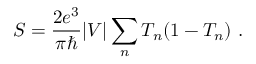Convert formula to latex. <formula><loc_0><loc_0><loc_500><loc_500>S = { \frac { 2 e ^ { 3 } } { \pi } } | V | \sum _ { n } T _ { n } ( 1 - T _ { n } ) \ .</formula> 